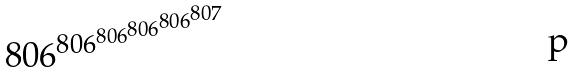<formula> <loc_0><loc_0><loc_500><loc_500>8 0 6 ^ { 8 0 6 ^ { 8 0 6 ^ { 8 0 6 ^ { 8 0 6 ^ { 8 0 7 } } } } }</formula> 